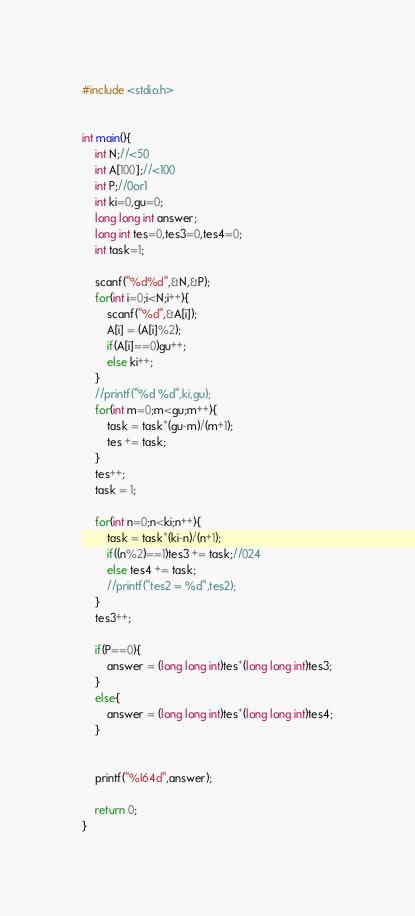Convert code to text. <code><loc_0><loc_0><loc_500><loc_500><_C_>#include <stdio.h>


int main(){
	int N;//<50
	int A[100];//<100
	int P;//0or1
	int ki=0,gu=0;
	long long int answer;
	long int tes=0,tes3=0,tes4=0;
	int task=1;

	scanf("%d%d",&N,&P);
	for(int i=0;i<N;i++){
		scanf("%d",&A[i]);
		A[i] = (A[i]%2);
		if(A[i]==0)gu++;
		else ki++;
	}
	//printf("%d %d",ki,gu);
	for(int m=0;m<gu;m++){
		task = task*(gu-m)/(m+1);
		tes += task;
	}
	tes++;
	task = 1;

	for(int n=0;n<ki;n++){
		task = task*(ki-n)/(n+1);
		if((n%2)==1)tes3 += task;//024
		else tes4 += task;
		//printf("tes2 = %d",tes2);
	}
	tes3++;

	if(P==0){
		answer = (long long int)tes*(long long int)tes3;
	}
	else{
		answer = (long long int)tes*(long long int)tes4;
	}


	printf("%I64d",answer);

	return 0;
}</code> 